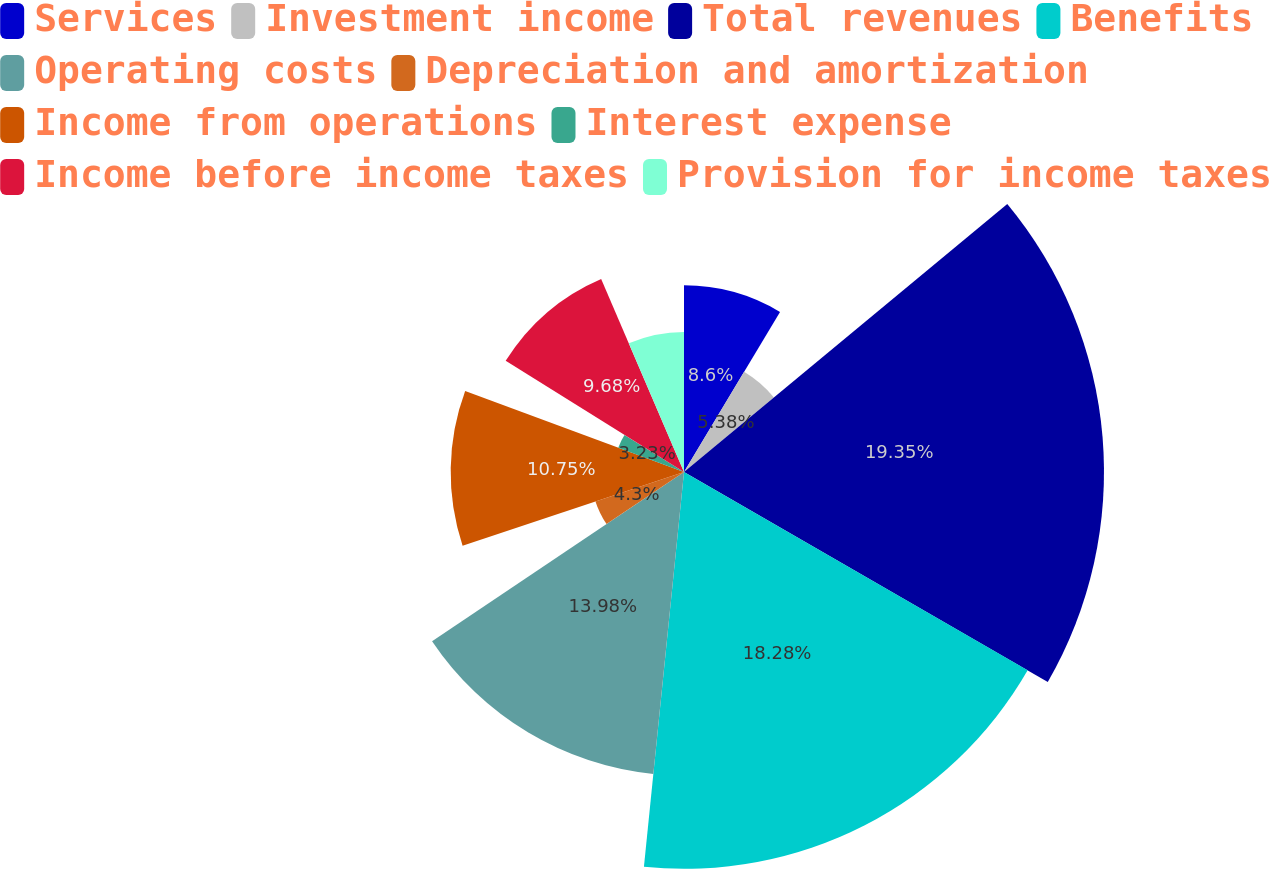Convert chart to OTSL. <chart><loc_0><loc_0><loc_500><loc_500><pie_chart><fcel>Services<fcel>Investment income<fcel>Total revenues<fcel>Benefits<fcel>Operating costs<fcel>Depreciation and amortization<fcel>Income from operations<fcel>Interest expense<fcel>Income before income taxes<fcel>Provision for income taxes<nl><fcel>8.6%<fcel>5.38%<fcel>19.35%<fcel>18.28%<fcel>13.98%<fcel>4.3%<fcel>10.75%<fcel>3.23%<fcel>9.68%<fcel>6.45%<nl></chart> 